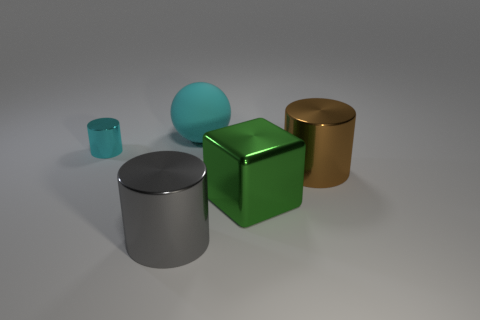Subtract all large brown cylinders. How many cylinders are left? 2 Add 3 tiny red cylinders. How many objects exist? 8 Subtract all balls. How many objects are left? 4 Subtract all brown cylinders. How many cylinders are left? 2 Subtract all purple cylinders. Subtract all brown blocks. How many cylinders are left? 3 Subtract 0 yellow cubes. How many objects are left? 5 Subtract 1 cubes. How many cubes are left? 0 Subtract all big gray objects. Subtract all large cyan spheres. How many objects are left? 3 Add 1 small cyan shiny cylinders. How many small cyan shiny cylinders are left? 2 Add 5 gray rubber cylinders. How many gray rubber cylinders exist? 5 